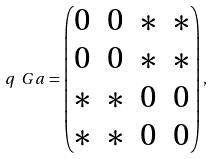<formula> <loc_0><loc_0><loc_500><loc_500>q _ { \ } G a = \begin{pmatrix} 0 & 0 & * & * \\ 0 & 0 & * & * \\ * & * & 0 & 0 \\ * & * & 0 & 0 \end{pmatrix} ,</formula> 